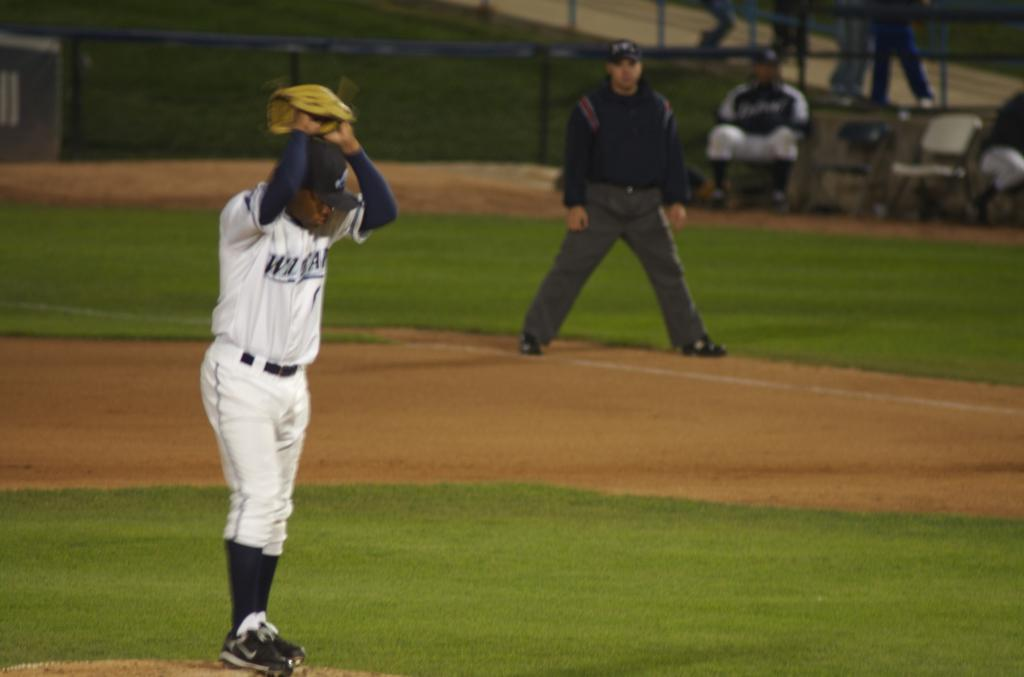What activity are the people in the image engaged in? There is a group of people playing a game in the image. Can you describe the setting of the image? There are persons sitting on chairs in the background of the image, and there is grass visible. What type of barrier is present in the image? There is fencing visible in the image. Can you see any cobwebs in the image? There is no mention of cobwebs in the provided facts, so we cannot determine if any are present in the image. 